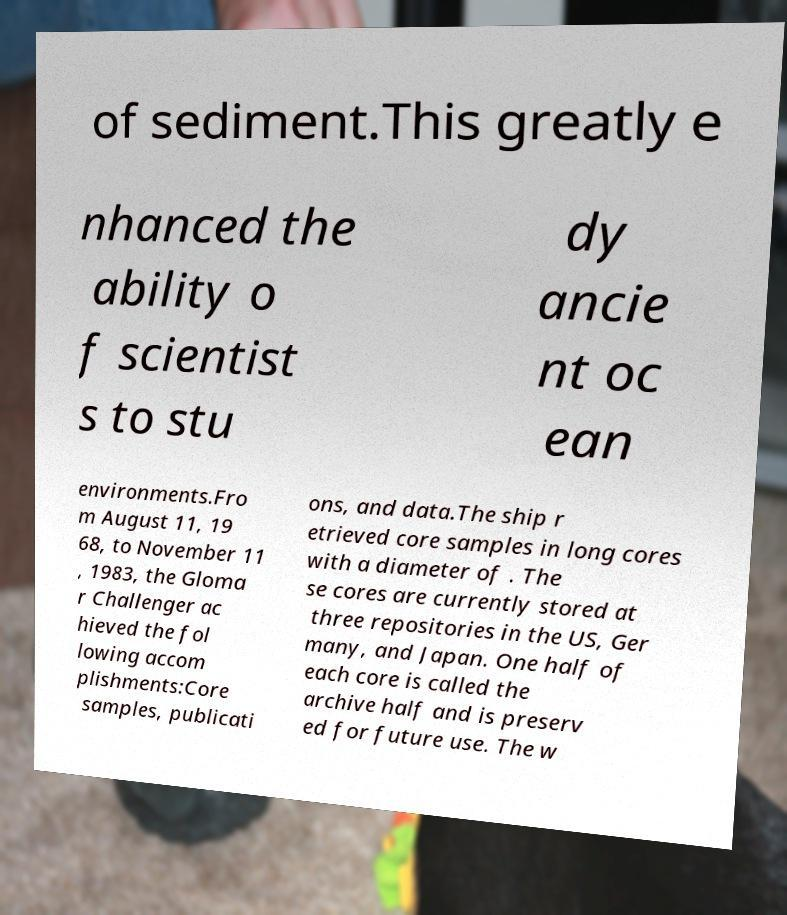Could you extract and type out the text from this image? of sediment.This greatly e nhanced the ability o f scientist s to stu dy ancie nt oc ean environments.Fro m August 11, 19 68, to November 11 , 1983, the Gloma r Challenger ac hieved the fol lowing accom plishments:Core samples, publicati ons, and data.The ship r etrieved core samples in long cores with a diameter of . The se cores are currently stored at three repositories in the US, Ger many, and Japan. One half of each core is called the archive half and is preserv ed for future use. The w 